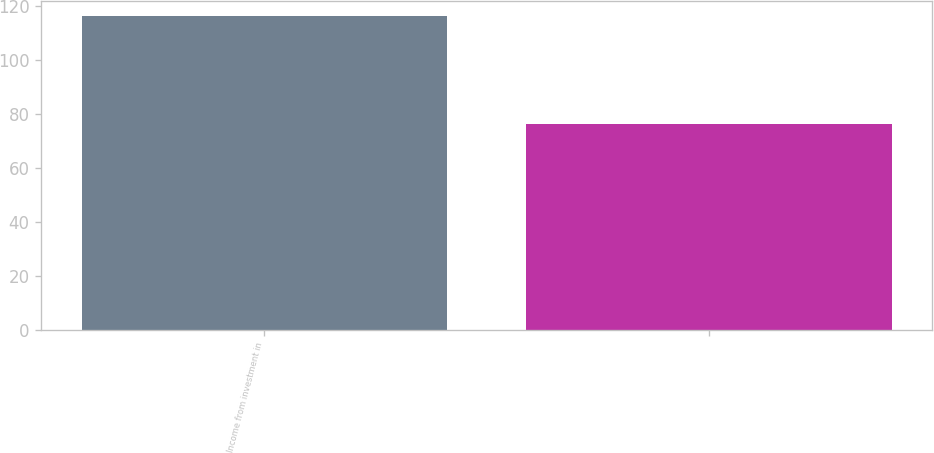<chart> <loc_0><loc_0><loc_500><loc_500><bar_chart><fcel>Income from investment in<fcel>Unnamed: 1<nl><fcel>116<fcel>76<nl></chart> 